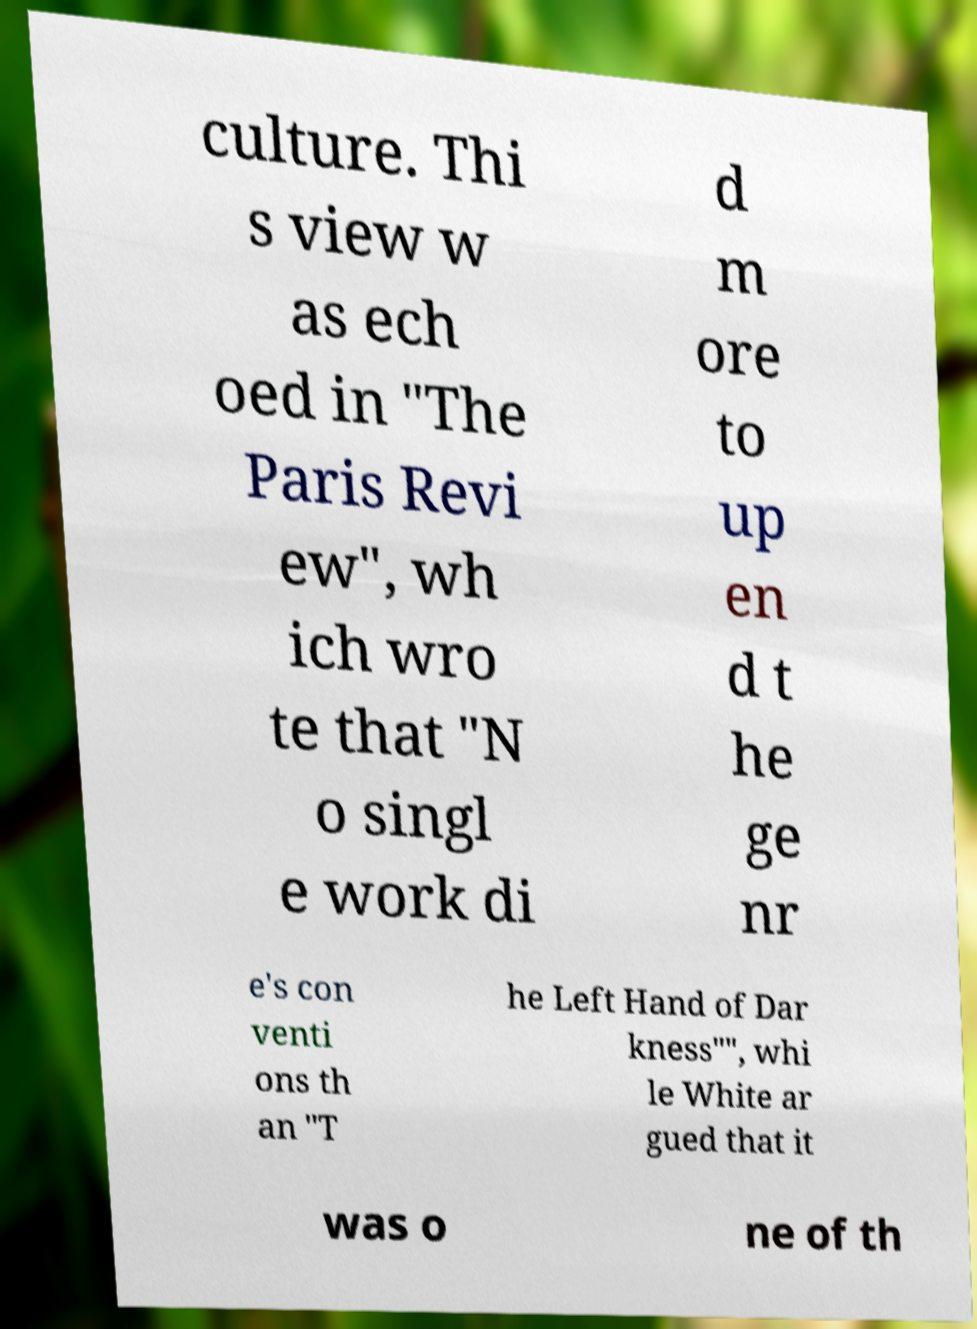There's text embedded in this image that I need extracted. Can you transcribe it verbatim? culture. Thi s view w as ech oed in "The Paris Revi ew", wh ich wro te that "N o singl e work di d m ore to up en d t he ge nr e's con venti ons th an "T he Left Hand of Dar kness"", whi le White ar gued that it was o ne of th 